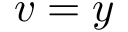Convert formula to latex. <formula><loc_0><loc_0><loc_500><loc_500>v = y</formula> 